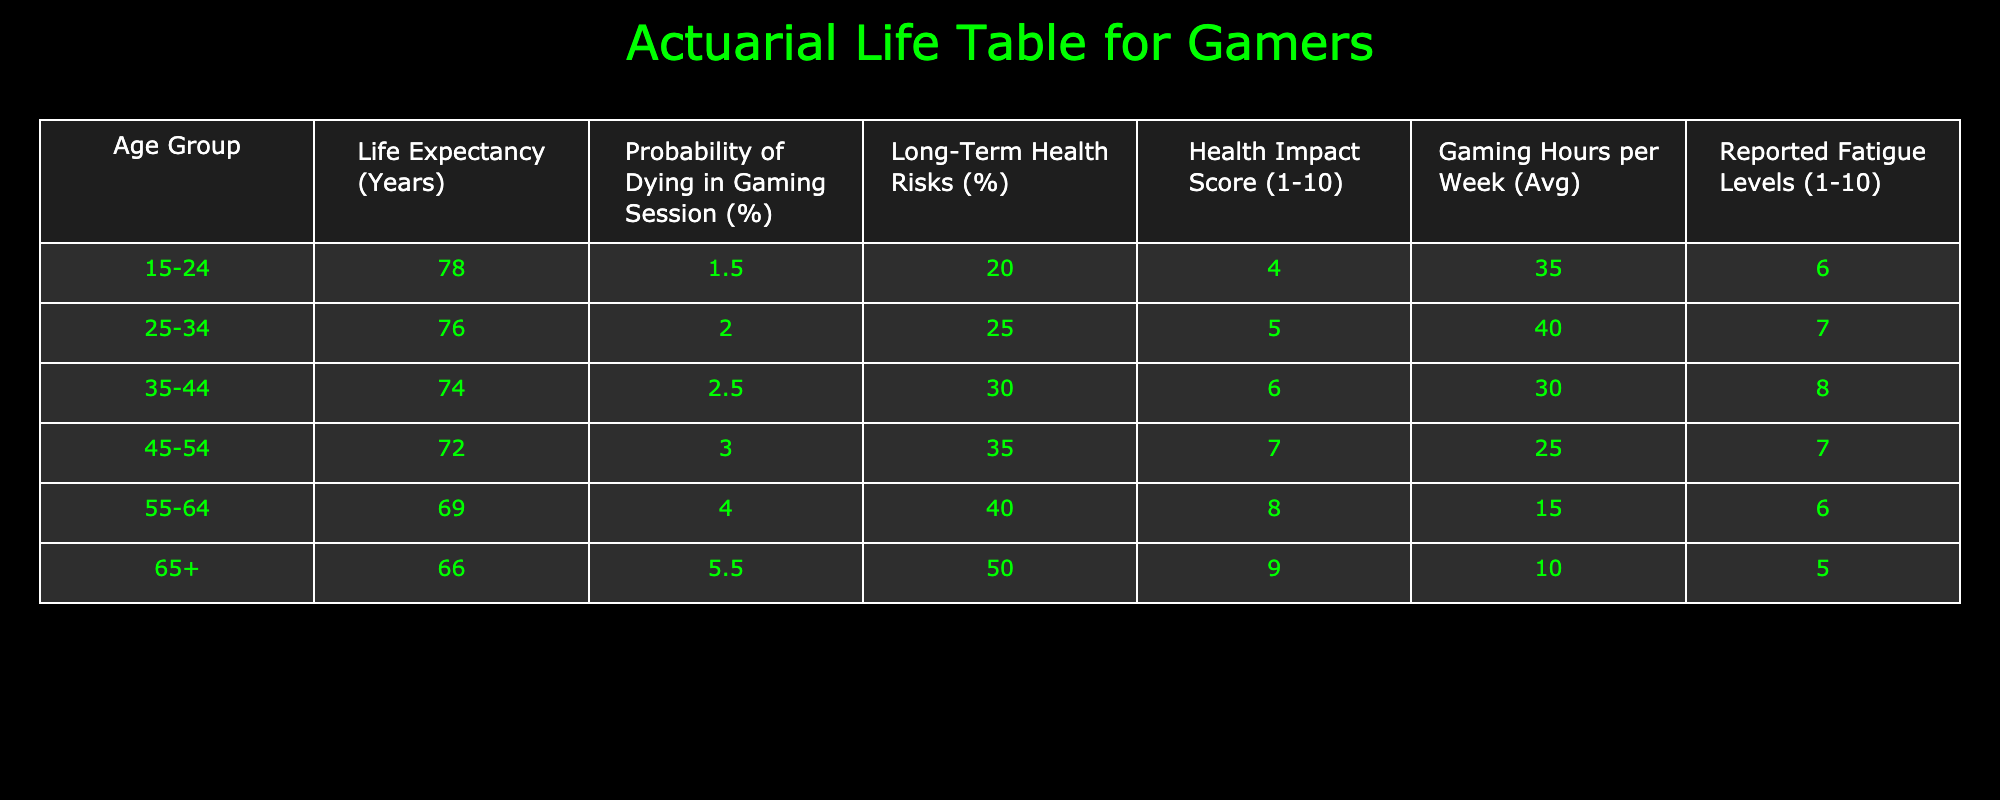What is the life expectancy of the 35-44 age group? According to the table, the life expectancy for the 35-44 age group is directly listed in the second column, which states 74 years.
Answer: 74 What is the probability of dying in a gaming session for individuals aged 25-34? The table indicates the probability of dying in a gaming session for the 25-34 age group in the third column, which is 2.0%.
Answer: 2.0% Which age group has the highest reported fatigue levels? Looking at the "Reported Fatigue Levels" column, the highest recorded value is 8, which corresponds to the 35-44 age group.
Answer: 35-44 What is the average probability of dying in a gaming session across all age groups? To find the average, add the probabilities: (1.5 + 2.0 + 2.5 + 3.0 + 4.0 + 5.5) = 18.5 and divide by 6 age groups, yielding an average of 3.083.
Answer: 3.083 Is the long-term health risk higher for the 45-54 age group compared to the 25-34 age group? Comparing the "Long-Term Health Risks" values in the table, the 45-54 age group has 35%, while the 25-34 age group has 25%. Therefore, it is true that the 45-54 group has higher long-term health risks.
Answer: Yes What is the total Health Impact Score for all age groups? The total Health Impact Score can be obtained by summing the scores from the score column: (4 + 5 + 6 + 7 + 8 + 9) = 39.
Answer: 39 Which age group has the lowest average gaming hours per week? By examining the "Gaming Hours per Week (Avg)" column, the 55-64 age group has the lowest average, which is 15 hours.
Answer: 55-64 Is the Health Impact Score greater than 6 for individuals aged 55 and older? The table shows that for ages 55-64, the Health Impact Score is 8, and for 65+, it is 9. Therefore, it is true that both groups have scores greater than 6.
Answer: Yes What is the difference in life expectancy between the 15-24 and 65+ age groups? The life expectancy for 15-24 is 78 years and for 65+, it is 66 years. The difference is 78 - 66 = 12 years.
Answer: 12 